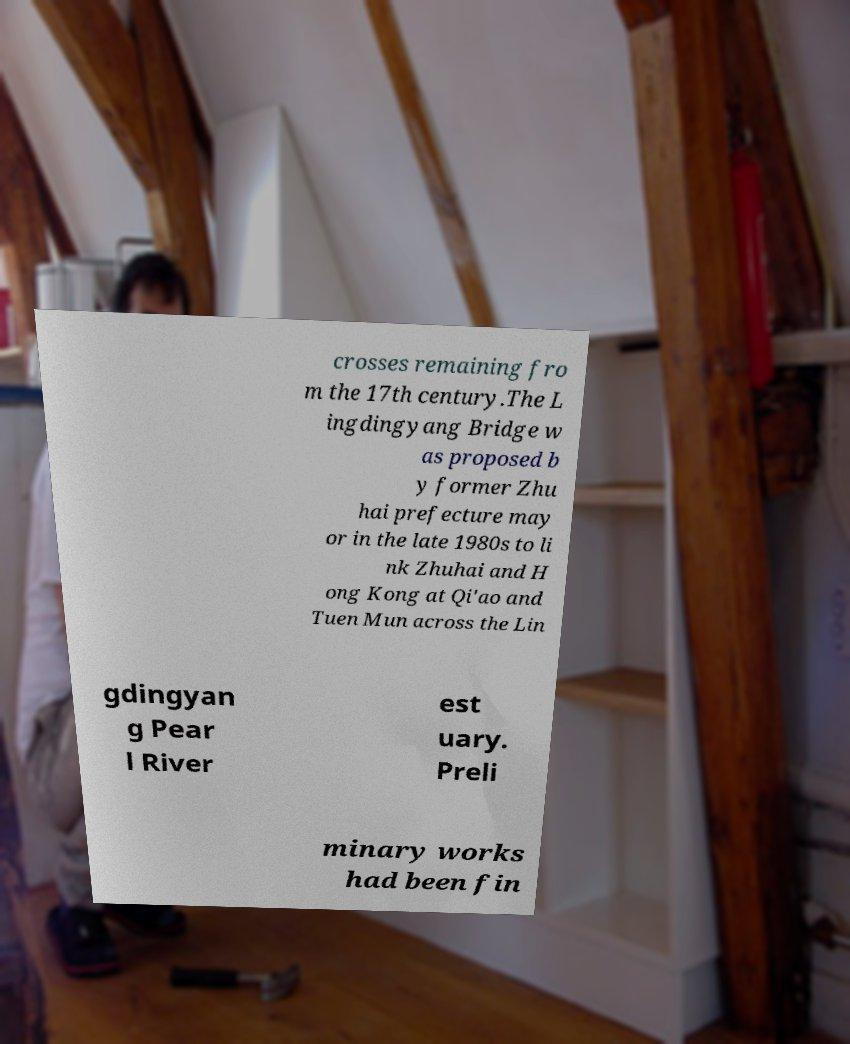Could you assist in decoding the text presented in this image and type it out clearly? crosses remaining fro m the 17th century.The L ingdingyang Bridge w as proposed b y former Zhu hai prefecture may or in the late 1980s to li nk Zhuhai and H ong Kong at Qi'ao and Tuen Mun across the Lin gdingyan g Pear l River est uary. Preli minary works had been fin 